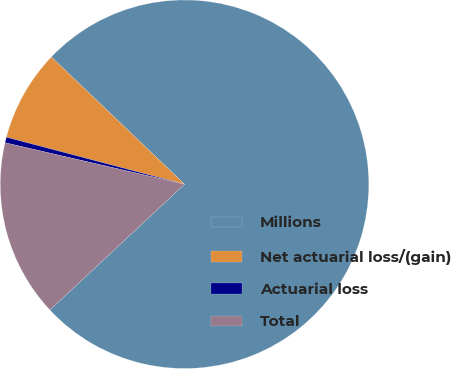<chart> <loc_0><loc_0><loc_500><loc_500><pie_chart><fcel>Millions<fcel>Net actuarial loss/(gain)<fcel>Actuarial loss<fcel>Total<nl><fcel>75.9%<fcel>8.03%<fcel>0.49%<fcel>15.57%<nl></chart> 